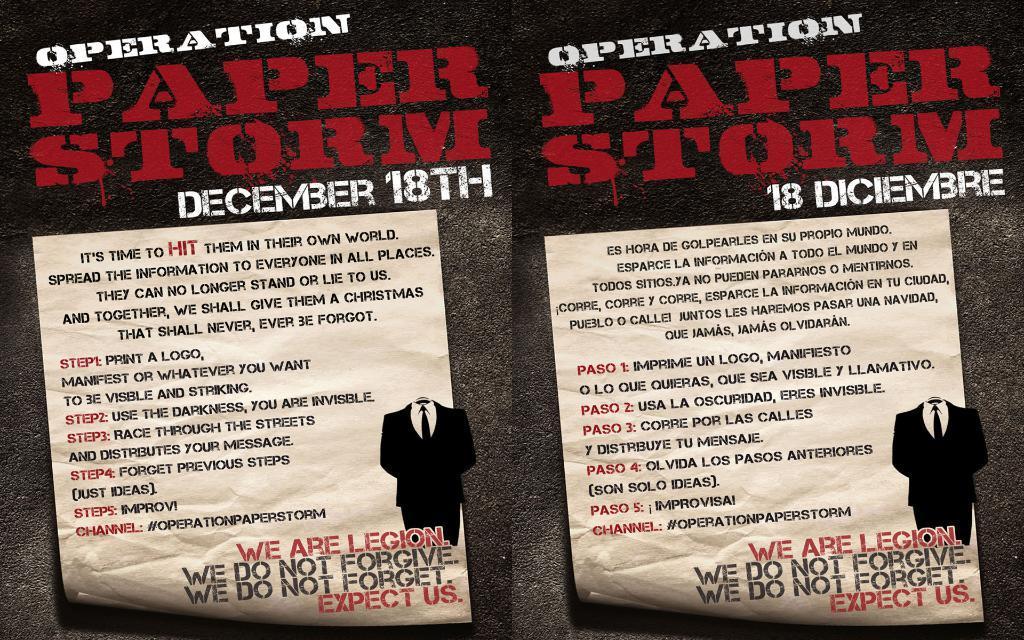Describe this image in one or two sentences. There is a collage image of two same pictures in different languages. In these pictures, we can see papers and some text. 